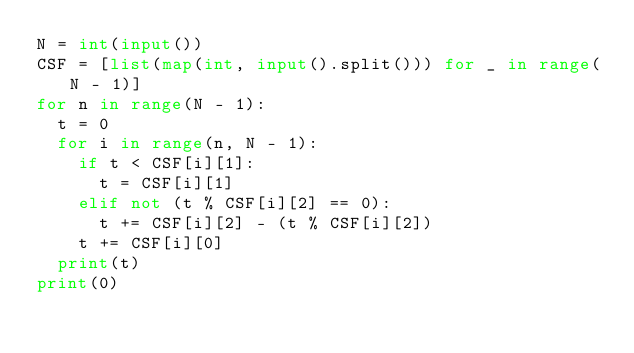Convert code to text. <code><loc_0><loc_0><loc_500><loc_500><_Python_>N = int(input())
CSF = [list(map(int, input().split())) for _ in range(N - 1)]
for n in range(N - 1):
  t = 0
  for i in range(n, N - 1):
    if t < CSF[i][1]:
      t = CSF[i][1]
    elif not (t % CSF[i][2] == 0):
      t += CSF[i][2] - (t % CSF[i][2])
    t += CSF[i][0]
  print(t)
print(0)
</code> 